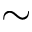<formula> <loc_0><loc_0><loc_500><loc_500>\sim</formula> 